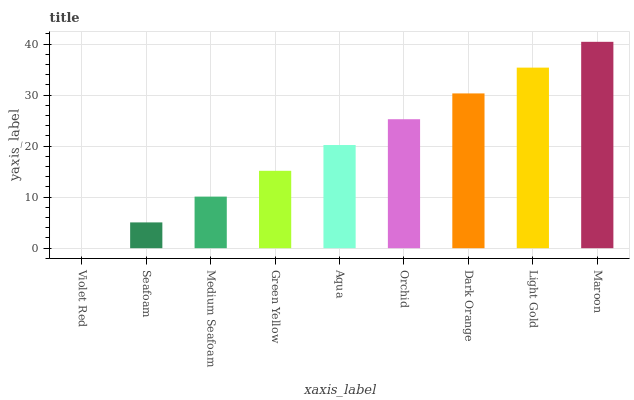Is Violet Red the minimum?
Answer yes or no. Yes. Is Maroon the maximum?
Answer yes or no. Yes. Is Seafoam the minimum?
Answer yes or no. No. Is Seafoam the maximum?
Answer yes or no. No. Is Seafoam greater than Violet Red?
Answer yes or no. Yes. Is Violet Red less than Seafoam?
Answer yes or no. Yes. Is Violet Red greater than Seafoam?
Answer yes or no. No. Is Seafoam less than Violet Red?
Answer yes or no. No. Is Aqua the high median?
Answer yes or no. Yes. Is Aqua the low median?
Answer yes or no. Yes. Is Violet Red the high median?
Answer yes or no. No. Is Light Gold the low median?
Answer yes or no. No. 